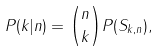<formula> <loc_0><loc_0><loc_500><loc_500>P ( k | n ) = \binom { n } { k } P ( S _ { k , n } ) ,</formula> 